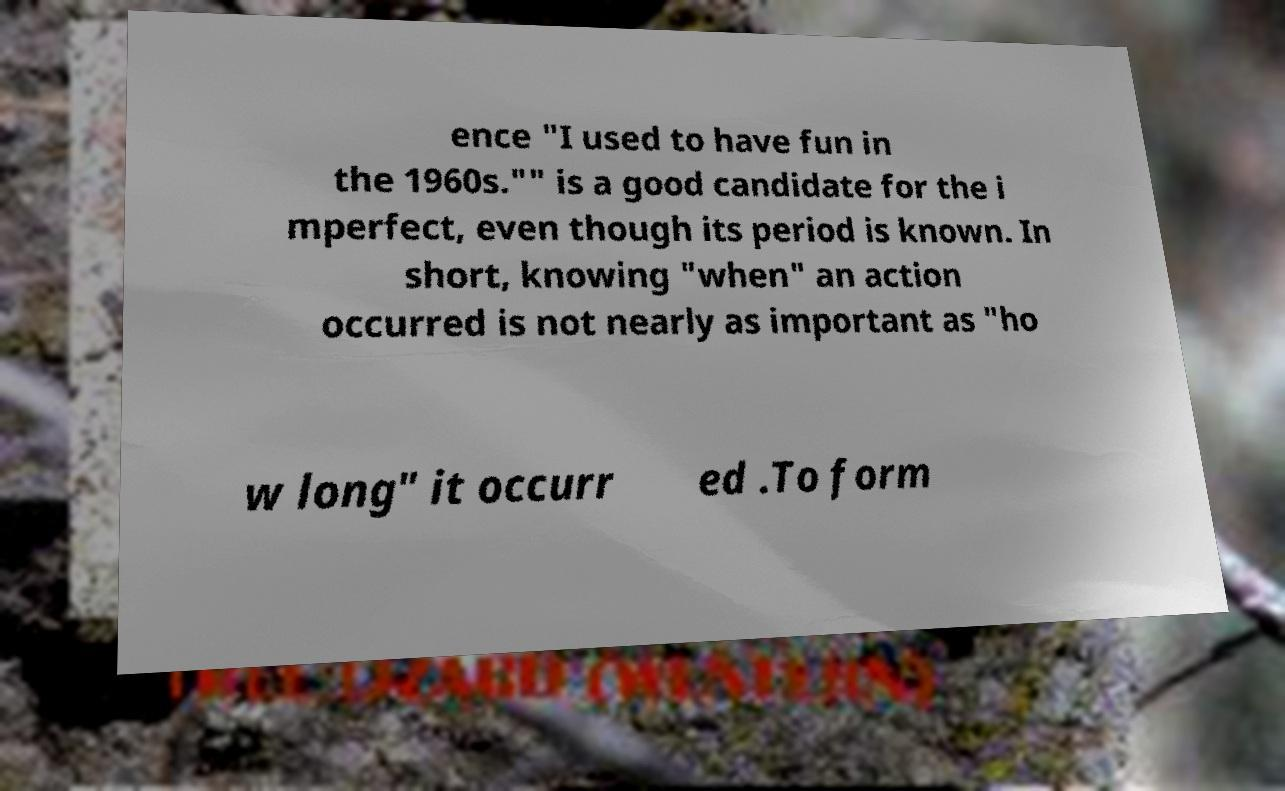Could you extract and type out the text from this image? ence "I used to have fun in the 1960s."" is a good candidate for the i mperfect, even though its period is known. In short, knowing "when" an action occurred is not nearly as important as "ho w long" it occurr ed .To form 